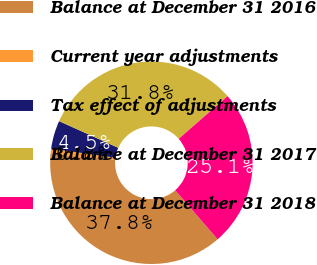Convert chart. <chart><loc_0><loc_0><loc_500><loc_500><pie_chart><fcel>Balance at December 31 2016<fcel>Current year adjustments<fcel>Tax effect of adjustments<fcel>Balance at December 31 2017<fcel>Balance at December 31 2018<nl><fcel>37.77%<fcel>0.82%<fcel>4.52%<fcel>31.82%<fcel>25.08%<nl></chart> 